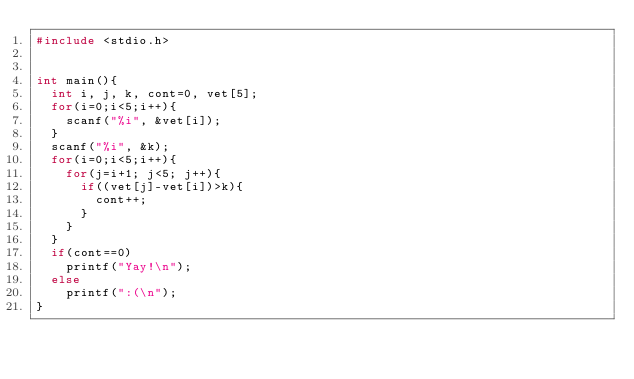<code> <loc_0><loc_0><loc_500><loc_500><_C_>#include <stdio.h>


int main(){
	int i, j, k, cont=0, vet[5];
	for(i=0;i<5;i++){
		scanf("%i", &vet[i]);
	}
	scanf("%i", &k);
	for(i=0;i<5;i++){
		for(j=i+1; j<5; j++){
			if((vet[j]-vet[i])>k){
				cont++;
			}
		}
	}
	if(cont==0)
		printf("Yay!\n");
	else
		printf(":(\n");
}</code> 